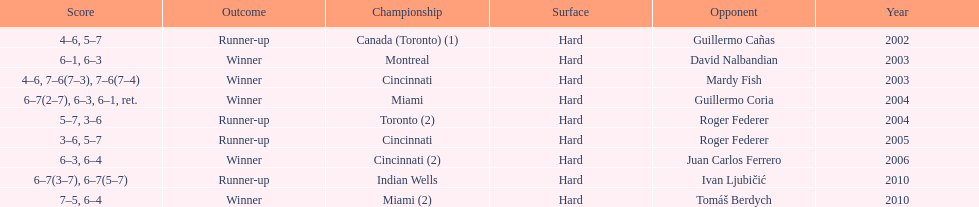How many times has he been runner-up? 4. Would you be able to parse every entry in this table? {'header': ['Score', 'Outcome', 'Championship', 'Surface', 'Opponent', 'Year'], 'rows': [['4–6, 5–7', 'Runner-up', 'Canada (Toronto) (1)', 'Hard', 'Guillermo Cañas', '2002'], ['6–1, 6–3', 'Winner', 'Montreal', 'Hard', 'David Nalbandian', '2003'], ['4–6, 7–6(7–3), 7–6(7–4)', 'Winner', 'Cincinnati', 'Hard', 'Mardy Fish', '2003'], ['6–7(2–7), 6–3, 6–1, ret.', 'Winner', 'Miami', 'Hard', 'Guillermo Coria', '2004'], ['5–7, 3–6', 'Runner-up', 'Toronto (2)', 'Hard', 'Roger Federer', '2004'], ['3–6, 5–7', 'Runner-up', 'Cincinnati', 'Hard', 'Roger Federer', '2005'], ['6–3, 6–4', 'Winner', 'Cincinnati (2)', 'Hard', 'Juan Carlos Ferrero', '2006'], ['6–7(3–7), 6–7(5–7)', 'Runner-up', 'Indian Wells', 'Hard', 'Ivan Ljubičić', '2010'], ['7–5, 6–4', 'Winner', 'Miami (2)', 'Hard', 'Tomáš Berdych', '2010']]} 